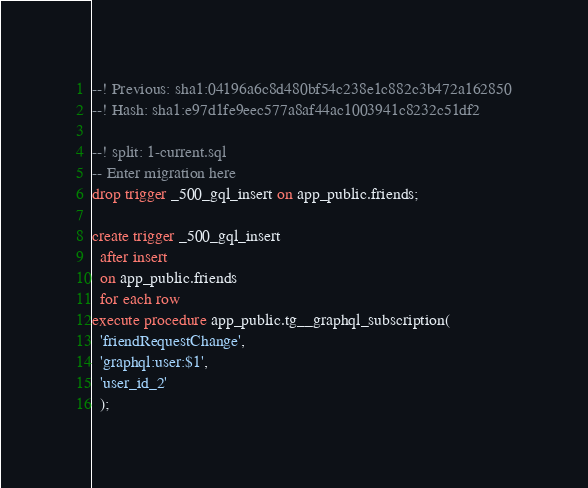Convert code to text. <code><loc_0><loc_0><loc_500><loc_500><_SQL_>--! Previous: sha1:04196a6c8d480bf54c238e1c882c3b472a162850
--! Hash: sha1:e97d1fe9eec577a8af44ac1003941c8232c51df2

--! split: 1-current.sql
-- Enter migration here
drop trigger _500_gql_insert on app_public.friends;

create trigger _500_gql_insert
  after insert
  on app_public.friends
  for each row
execute procedure app_public.tg__graphql_subscription(
  'friendRequestChange',
  'graphql:user:$1',
  'user_id_2'
  );
</code> 